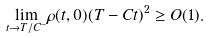<formula> <loc_0><loc_0><loc_500><loc_500>\underset { t \rightarrow T / C ^ { - } } { \lim } \rho ( t , 0 ) ( T - C t ) ^ { 2 } \geq O ( 1 ) .</formula> 